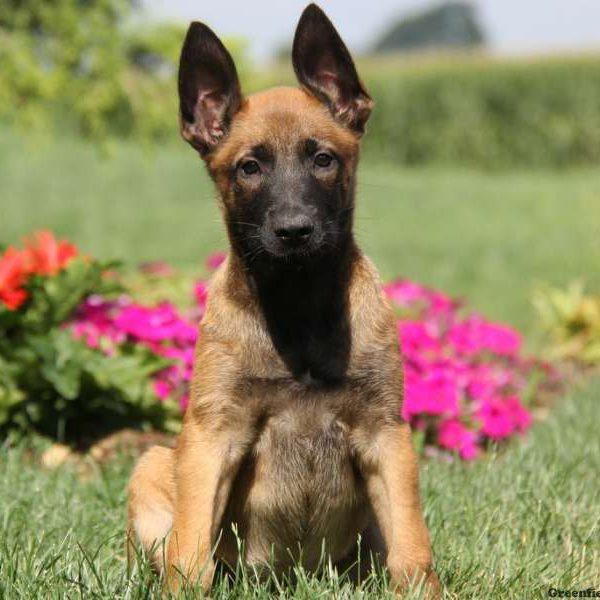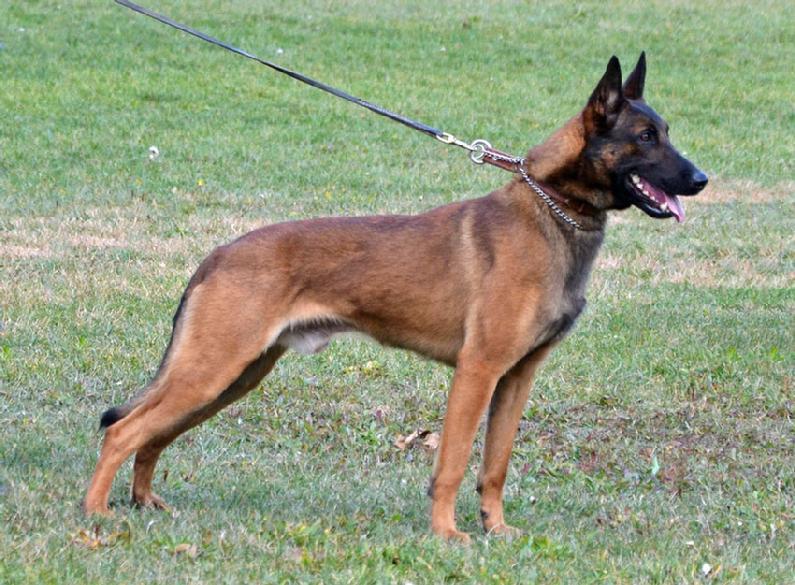The first image is the image on the left, the second image is the image on the right. For the images shown, is this caption "The dog in the image on the right is lying in a grassy area." true? Answer yes or no. No. The first image is the image on the left, the second image is the image on the right. For the images displayed, is the sentence "An image shows someone wearing jeans standing behind a german shepherd dog." factually correct? Answer yes or no. No. 